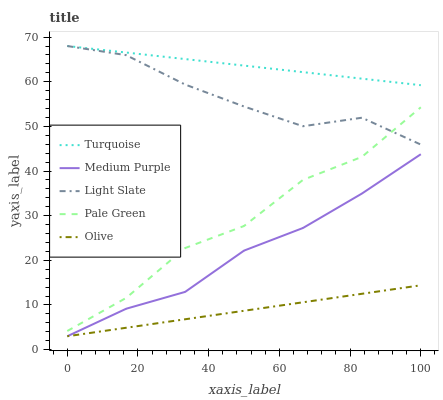Does Light Slate have the minimum area under the curve?
Answer yes or no. No. Does Light Slate have the maximum area under the curve?
Answer yes or no. No. Is Light Slate the smoothest?
Answer yes or no. No. Is Light Slate the roughest?
Answer yes or no. No. Does Light Slate have the lowest value?
Answer yes or no. No. Does Pale Green have the highest value?
Answer yes or no. No. Is Olive less than Light Slate?
Answer yes or no. Yes. Is Turquoise greater than Pale Green?
Answer yes or no. Yes. Does Olive intersect Light Slate?
Answer yes or no. No. 